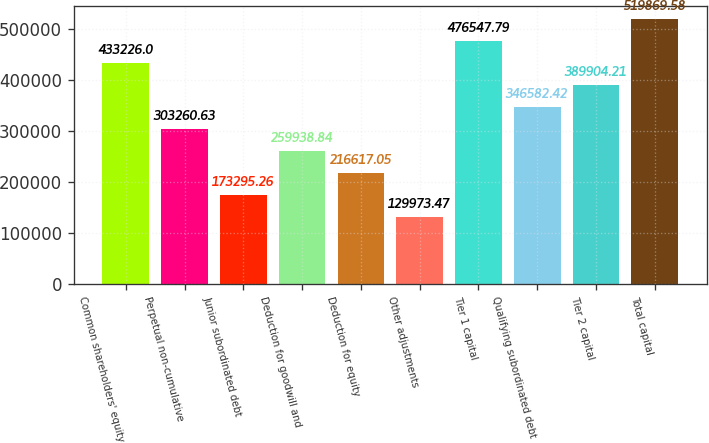Convert chart to OTSL. <chart><loc_0><loc_0><loc_500><loc_500><bar_chart><fcel>Common shareholders' equity<fcel>Perpetual non-cumulative<fcel>Junior subordinated debt<fcel>Deduction for goodwill and<fcel>Deduction for equity<fcel>Other adjustments<fcel>Tier 1 capital<fcel>Qualifying subordinated debt<fcel>Tier 2 capital<fcel>Total capital<nl><fcel>433226<fcel>303261<fcel>173295<fcel>259939<fcel>216617<fcel>129973<fcel>476548<fcel>346582<fcel>389904<fcel>519870<nl></chart> 